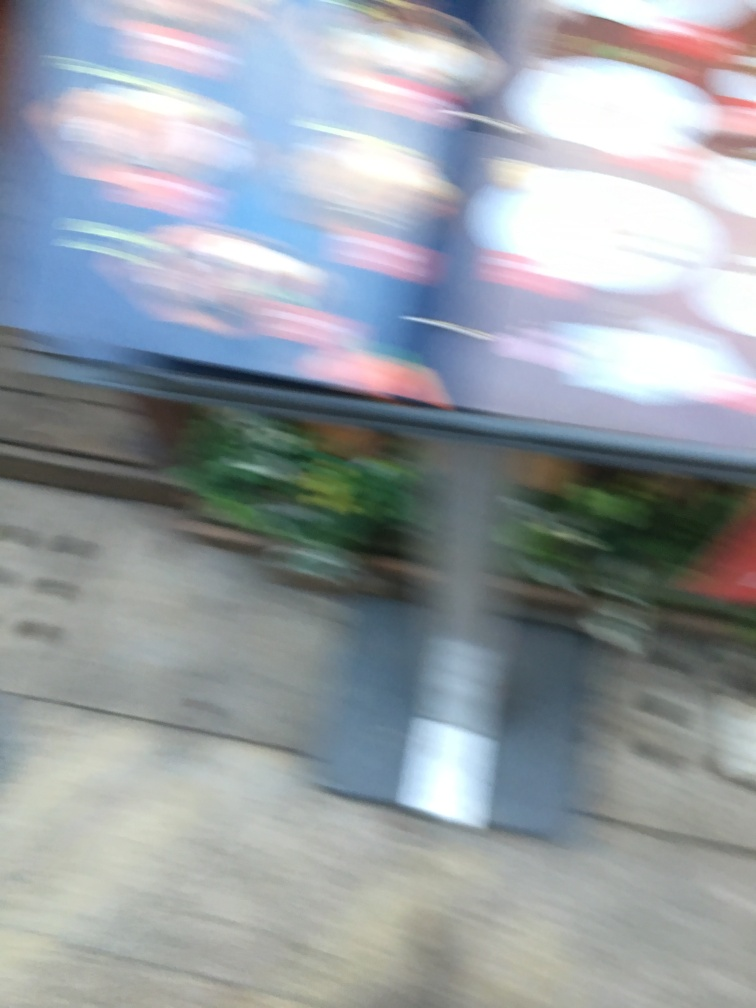In what situations could a blurry image like this be artistically intentional? An image with intentional blur might be used to convey a sense of movement, to create a dreamy or ethereal atmosphere, or to focus attention on a particular part of the image by blurring the surroundings. 